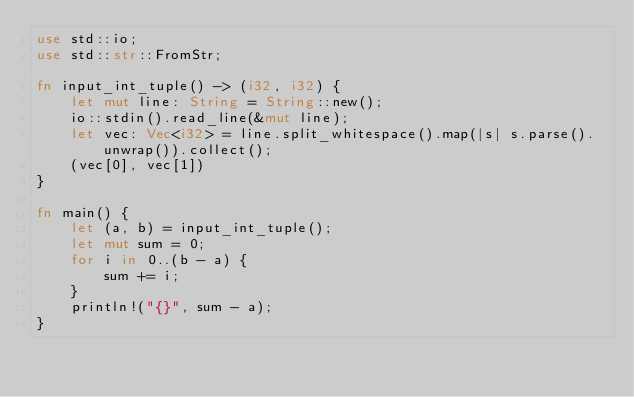Convert code to text. <code><loc_0><loc_0><loc_500><loc_500><_Rust_>use std::io;
use std::str::FromStr;

fn input_int_tuple() -> (i32, i32) {
    let mut line: String = String::new();
    io::stdin().read_line(&mut line);
    let vec: Vec<i32> = line.split_whitespace().map(|s| s.parse().unwrap()).collect();
    (vec[0], vec[1])
}

fn main() {
    let (a, b) = input_int_tuple();
    let mut sum = 0;
    for i in 0..(b - a) {
        sum += i;
    }
    println!("{}", sum - a);
}
</code> 